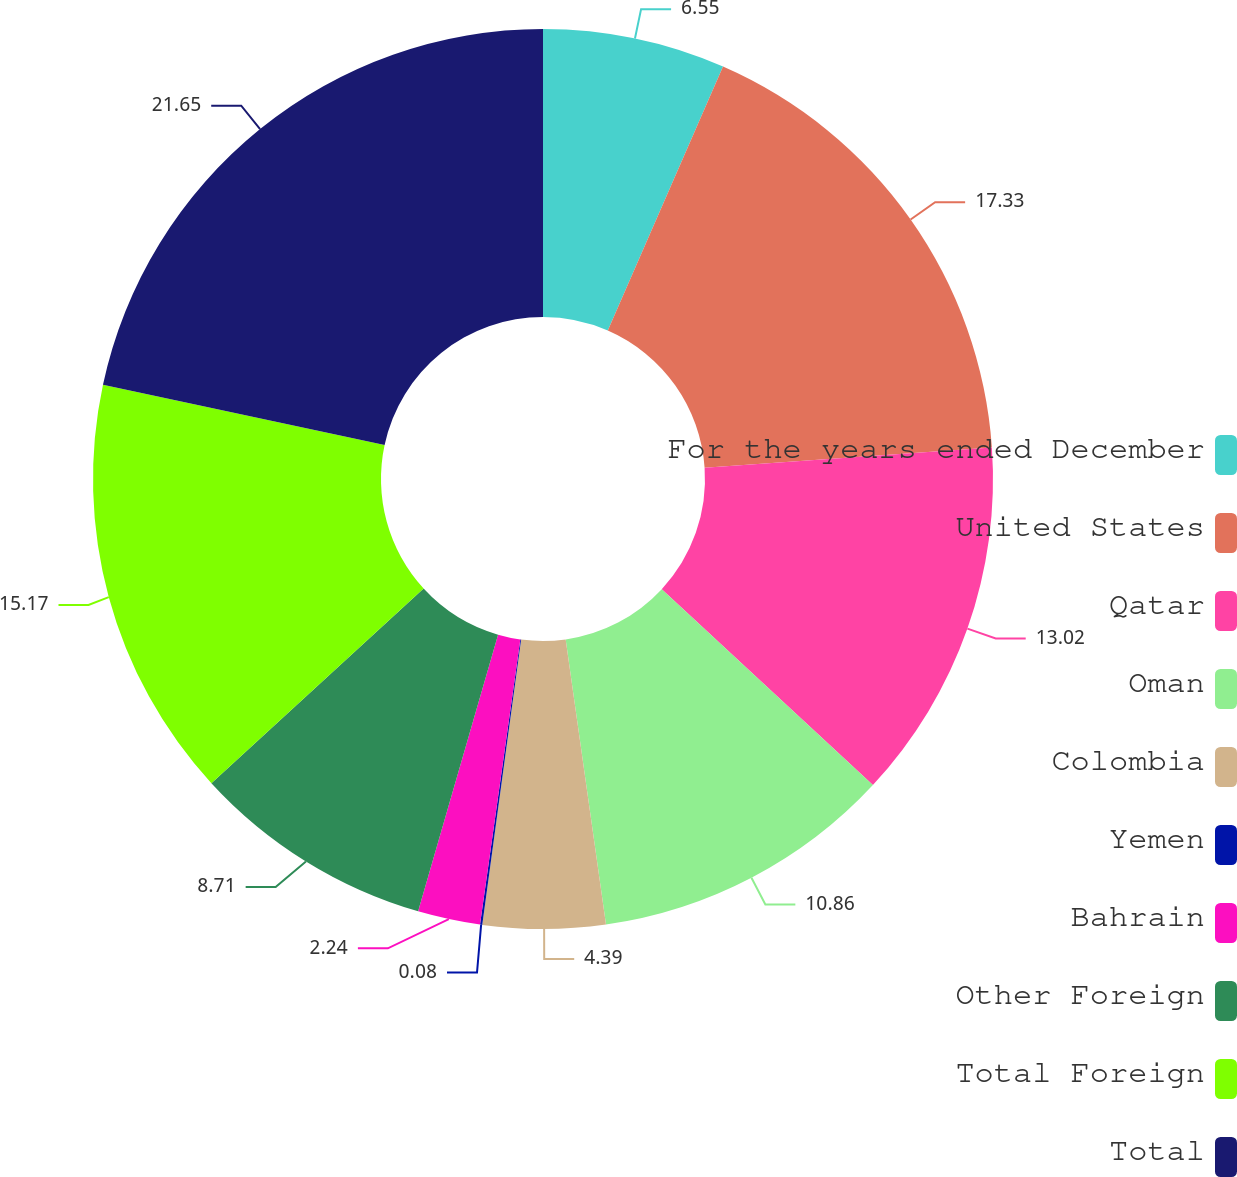Convert chart. <chart><loc_0><loc_0><loc_500><loc_500><pie_chart><fcel>For the years ended December<fcel>United States<fcel>Qatar<fcel>Oman<fcel>Colombia<fcel>Yemen<fcel>Bahrain<fcel>Other Foreign<fcel>Total Foreign<fcel>Total<nl><fcel>6.55%<fcel>17.33%<fcel>13.02%<fcel>10.86%<fcel>4.39%<fcel>0.08%<fcel>2.24%<fcel>8.71%<fcel>15.17%<fcel>21.64%<nl></chart> 